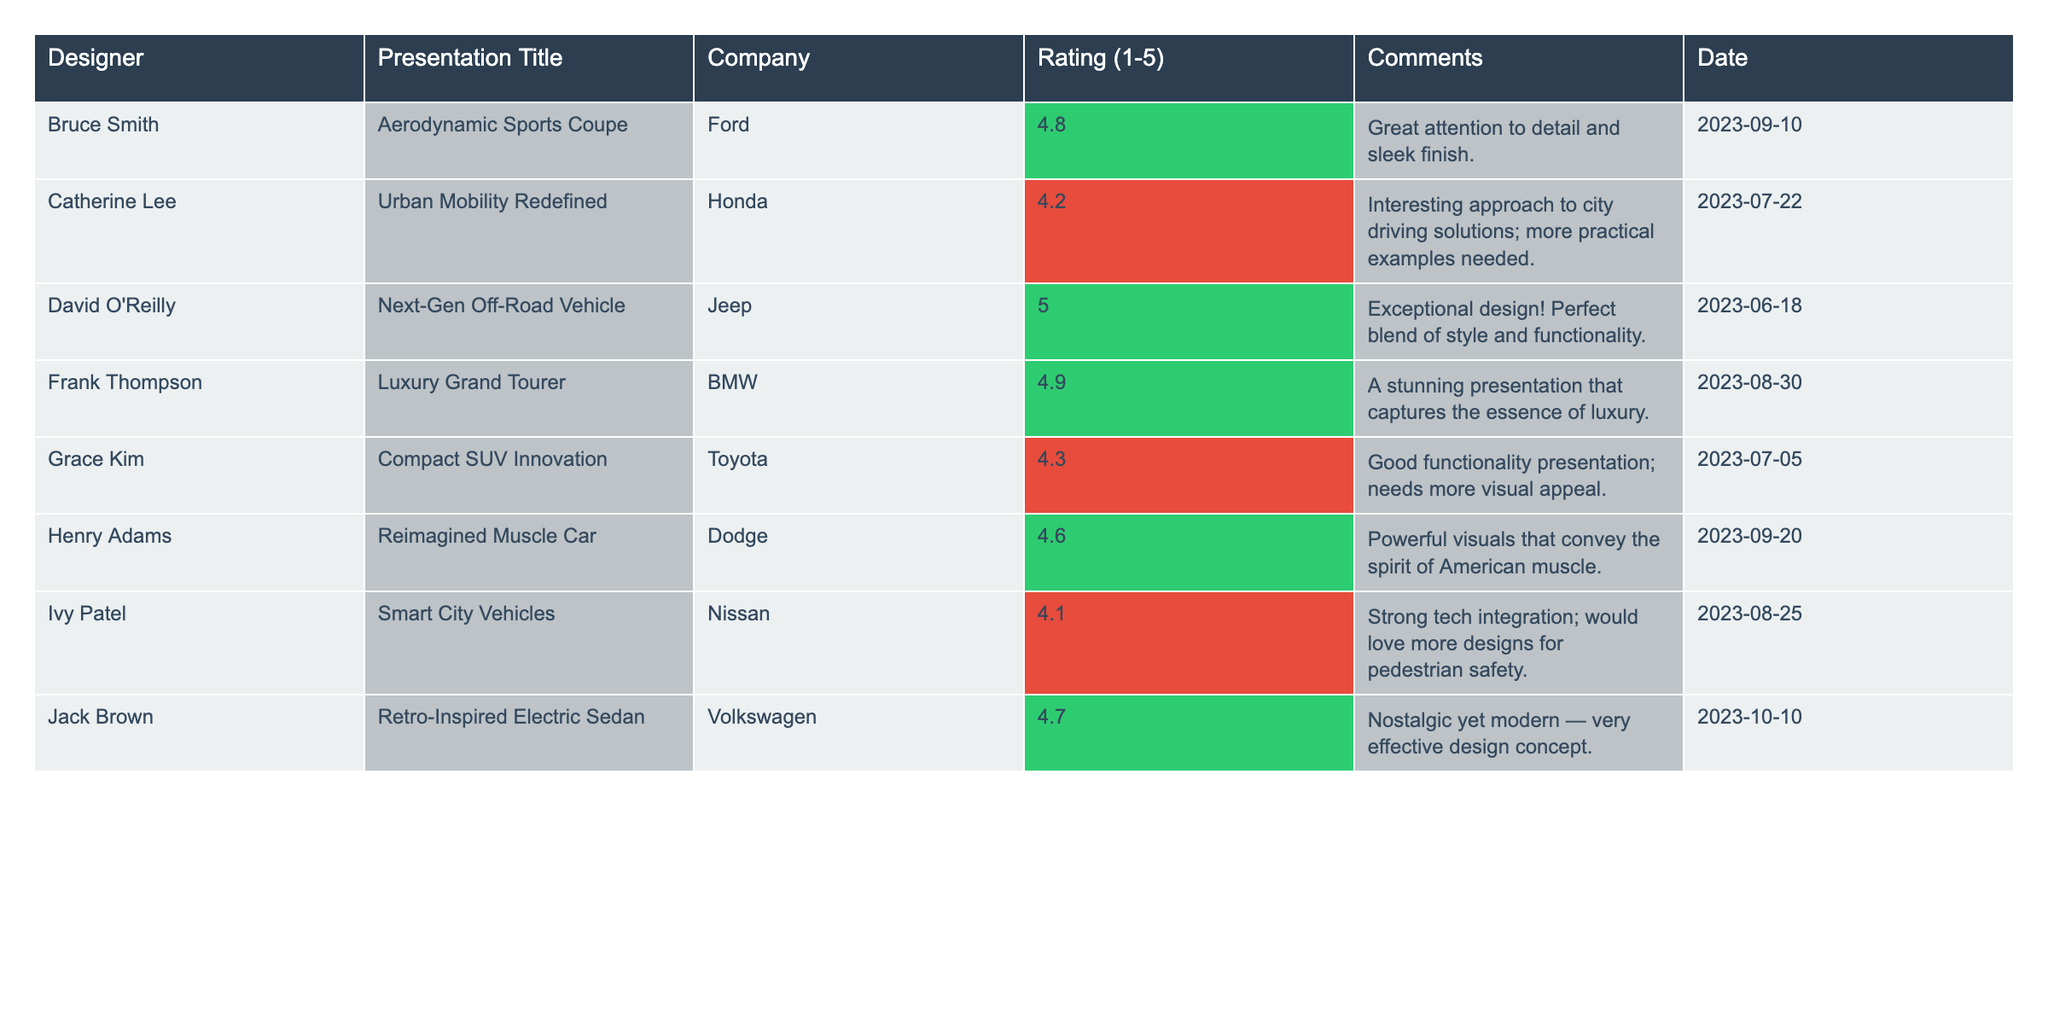What is the highest rating received for a presentation? The ratings in the table range from 4.1 to 5.0. Scanning through the ratings, the highest rating of 5.0 is identified associated with David O'Reilly's presentation on "Next-Gen Off-Road Vehicle."
Answer: 5.0 Who presented the "Luxury Grand Tourer" and what was their rating? The table shows that the "Luxury Grand Tourer" was presented by Frank Thompson, and his rating was 4.9.
Answer: Frank Thompson, 4.9 How many presentations received a rating of 4.5 or higher? There are a total of 8 presentations listed. Out of these, Bruce Smith, David O'Reilly, Frank Thompson, Henry Adams, Jack Brown, and Grace Kim all received ratings of 4.5 or higher, which sums up to 6 presentations.
Answer: 6 What is the average rating for the presentations listed? To find the average, we sum up the ratings: 4.8 + 4.2 + 5.0 + 4.9 + 4.3 + 4.6 + 4.1 + 4.7 = 36.6. Then we divide by the total number of ratings, which is 8, resulting in an average of 4.575.
Answer: 4.575 Which company had the highest-rated presentation? David O'Reilly's presentation for Jeep received the highest rating of 5.0, making it the highest-rated presentation in the table, attributed to the company Jeep.
Answer: Jeep Did any presentations receive a rating below 4.5? Checking the ratings, Ivy Patel's presentation for Nissan has a rating of 4.1, which is below 4.5. Thus, the answer is yes.
Answer: Yes What is the difference in rating between the highest and lowest-rated presentations? The highest rating is 5.0 (David O'Reilly's presentation), and the lowest rating is 4.1 (Ivy Patel's presentation). The difference is calculated as 5.0 - 4.1 = 0.9.
Answer: 0.9 Which presentation received comments indicating a need for more visual appeal? The comments for Grace Kim's "Compact SUV Innovation" mention that it "needs more visual appeal," identifying it as the presentation in question.
Answer: Compact SUV Innovation Which designer had a presentation titled "Retro-Inspired Electric Sedan"? The table provides that Jack Brown is the designer associated with the presentation titled "Retro-Inspired Electric Sedan."
Answer: Jack Brown Was any presentation rated exactly 4.2? Looking through the ratings, there is one presentation, "Urban Mobility Redefined" by Catherine Lee, which is rated exactly 4.2. Therefore, the answer is yes.
Answer: Yes 